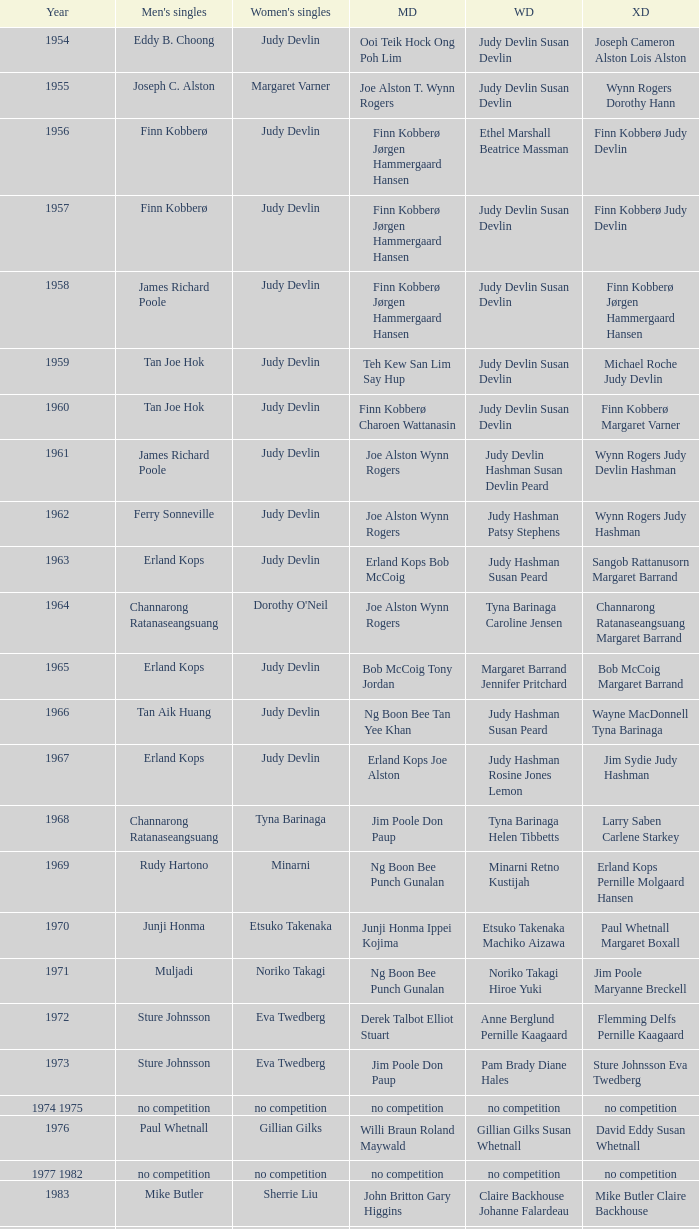Who were the men's doubles champions when the men's singles champion was muljadi? Ng Boon Bee Punch Gunalan. 